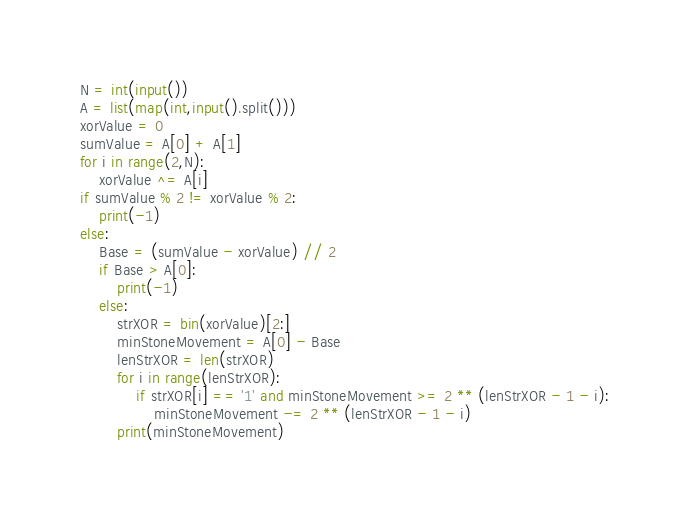Convert code to text. <code><loc_0><loc_0><loc_500><loc_500><_Python_>N = int(input())
A = list(map(int,input().split()))
xorValue = 0
sumValue = A[0] + A[1]
for i in range(2,N):
    xorValue ^= A[i]
if sumValue % 2 != xorValue % 2:
    print(-1)
else:
    Base = (sumValue - xorValue) // 2
    if Base > A[0]:
        print(-1)
    else:
        strXOR = bin(xorValue)[2:]
        minStoneMovement = A[0] - Base
        lenStrXOR = len(strXOR)
        for i in range(lenStrXOR):
            if strXOR[i] == '1' and minStoneMovement >= 2 ** (lenStrXOR - 1 - i):
                minStoneMovement -= 2 ** (lenStrXOR - 1 - i)
        print(minStoneMovement)</code> 